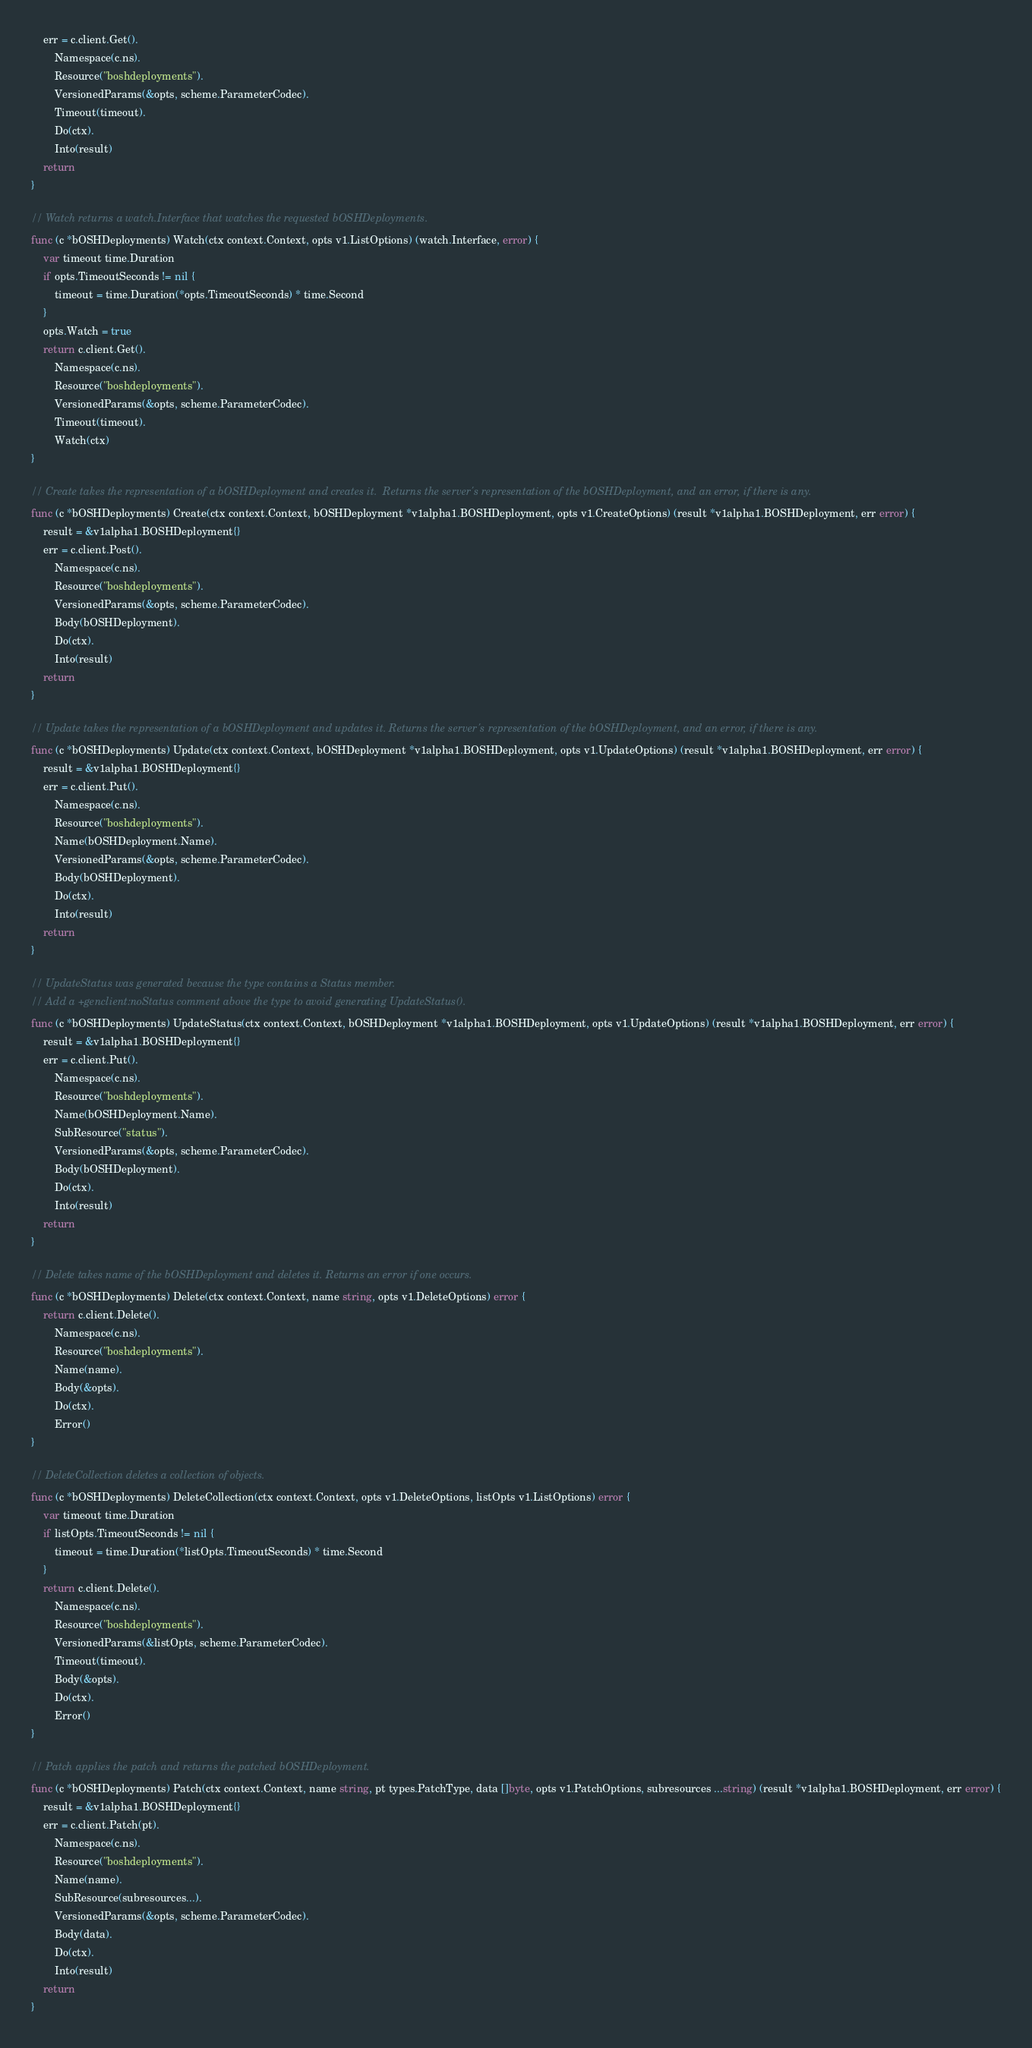Convert code to text. <code><loc_0><loc_0><loc_500><loc_500><_Go_>	err = c.client.Get().
		Namespace(c.ns).
		Resource("boshdeployments").
		VersionedParams(&opts, scheme.ParameterCodec).
		Timeout(timeout).
		Do(ctx).
		Into(result)
	return
}

// Watch returns a watch.Interface that watches the requested bOSHDeployments.
func (c *bOSHDeployments) Watch(ctx context.Context, opts v1.ListOptions) (watch.Interface, error) {
	var timeout time.Duration
	if opts.TimeoutSeconds != nil {
		timeout = time.Duration(*opts.TimeoutSeconds) * time.Second
	}
	opts.Watch = true
	return c.client.Get().
		Namespace(c.ns).
		Resource("boshdeployments").
		VersionedParams(&opts, scheme.ParameterCodec).
		Timeout(timeout).
		Watch(ctx)
}

// Create takes the representation of a bOSHDeployment and creates it.  Returns the server's representation of the bOSHDeployment, and an error, if there is any.
func (c *bOSHDeployments) Create(ctx context.Context, bOSHDeployment *v1alpha1.BOSHDeployment, opts v1.CreateOptions) (result *v1alpha1.BOSHDeployment, err error) {
	result = &v1alpha1.BOSHDeployment{}
	err = c.client.Post().
		Namespace(c.ns).
		Resource("boshdeployments").
		VersionedParams(&opts, scheme.ParameterCodec).
		Body(bOSHDeployment).
		Do(ctx).
		Into(result)
	return
}

// Update takes the representation of a bOSHDeployment and updates it. Returns the server's representation of the bOSHDeployment, and an error, if there is any.
func (c *bOSHDeployments) Update(ctx context.Context, bOSHDeployment *v1alpha1.BOSHDeployment, opts v1.UpdateOptions) (result *v1alpha1.BOSHDeployment, err error) {
	result = &v1alpha1.BOSHDeployment{}
	err = c.client.Put().
		Namespace(c.ns).
		Resource("boshdeployments").
		Name(bOSHDeployment.Name).
		VersionedParams(&opts, scheme.ParameterCodec).
		Body(bOSHDeployment).
		Do(ctx).
		Into(result)
	return
}

// UpdateStatus was generated because the type contains a Status member.
// Add a +genclient:noStatus comment above the type to avoid generating UpdateStatus().
func (c *bOSHDeployments) UpdateStatus(ctx context.Context, bOSHDeployment *v1alpha1.BOSHDeployment, opts v1.UpdateOptions) (result *v1alpha1.BOSHDeployment, err error) {
	result = &v1alpha1.BOSHDeployment{}
	err = c.client.Put().
		Namespace(c.ns).
		Resource("boshdeployments").
		Name(bOSHDeployment.Name).
		SubResource("status").
		VersionedParams(&opts, scheme.ParameterCodec).
		Body(bOSHDeployment).
		Do(ctx).
		Into(result)
	return
}

// Delete takes name of the bOSHDeployment and deletes it. Returns an error if one occurs.
func (c *bOSHDeployments) Delete(ctx context.Context, name string, opts v1.DeleteOptions) error {
	return c.client.Delete().
		Namespace(c.ns).
		Resource("boshdeployments").
		Name(name).
		Body(&opts).
		Do(ctx).
		Error()
}

// DeleteCollection deletes a collection of objects.
func (c *bOSHDeployments) DeleteCollection(ctx context.Context, opts v1.DeleteOptions, listOpts v1.ListOptions) error {
	var timeout time.Duration
	if listOpts.TimeoutSeconds != nil {
		timeout = time.Duration(*listOpts.TimeoutSeconds) * time.Second
	}
	return c.client.Delete().
		Namespace(c.ns).
		Resource("boshdeployments").
		VersionedParams(&listOpts, scheme.ParameterCodec).
		Timeout(timeout).
		Body(&opts).
		Do(ctx).
		Error()
}

// Patch applies the patch and returns the patched bOSHDeployment.
func (c *bOSHDeployments) Patch(ctx context.Context, name string, pt types.PatchType, data []byte, opts v1.PatchOptions, subresources ...string) (result *v1alpha1.BOSHDeployment, err error) {
	result = &v1alpha1.BOSHDeployment{}
	err = c.client.Patch(pt).
		Namespace(c.ns).
		Resource("boshdeployments").
		Name(name).
		SubResource(subresources...).
		VersionedParams(&opts, scheme.ParameterCodec).
		Body(data).
		Do(ctx).
		Into(result)
	return
}
</code> 